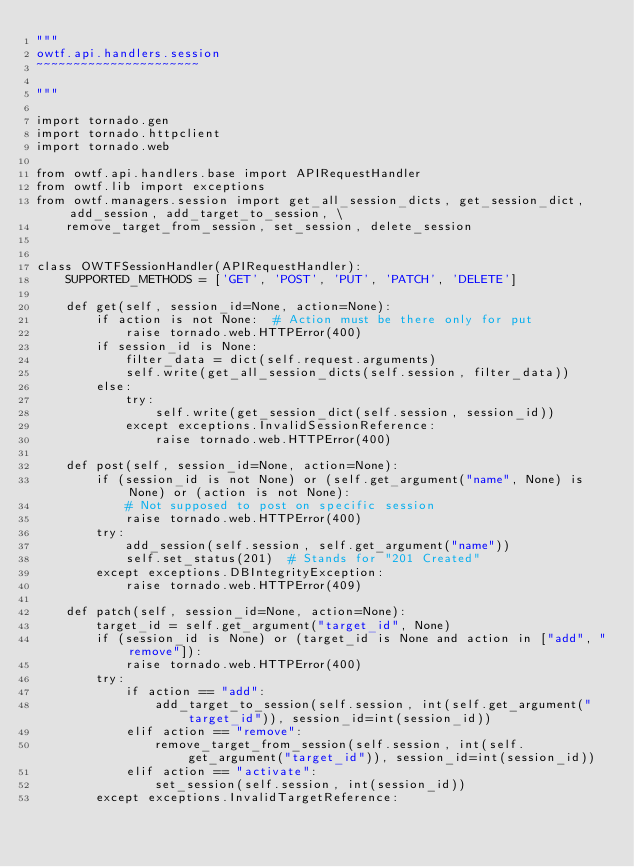Convert code to text. <code><loc_0><loc_0><loc_500><loc_500><_Python_>"""
owtf.api.handlers.session
~~~~~~~~~~~~~~~~~~~~~~

"""

import tornado.gen
import tornado.httpclient
import tornado.web

from owtf.api.handlers.base import APIRequestHandler
from owtf.lib import exceptions
from owtf.managers.session import get_all_session_dicts, get_session_dict, add_session, add_target_to_session, \
    remove_target_from_session, set_session, delete_session


class OWTFSessionHandler(APIRequestHandler):
    SUPPORTED_METHODS = ['GET', 'POST', 'PUT', 'PATCH', 'DELETE']

    def get(self, session_id=None, action=None):
        if action is not None:  # Action must be there only for put
            raise tornado.web.HTTPError(400)
        if session_id is None:
            filter_data = dict(self.request.arguments)
            self.write(get_all_session_dicts(self.session, filter_data))
        else:
            try:
                self.write(get_session_dict(self.session, session_id))
            except exceptions.InvalidSessionReference:
                raise tornado.web.HTTPError(400)

    def post(self, session_id=None, action=None):
        if (session_id is not None) or (self.get_argument("name", None) is None) or (action is not None):
            # Not supposed to post on specific session
            raise tornado.web.HTTPError(400)
        try:
            add_session(self.session, self.get_argument("name"))
            self.set_status(201)  # Stands for "201 Created"
        except exceptions.DBIntegrityException:
            raise tornado.web.HTTPError(409)

    def patch(self, session_id=None, action=None):
        target_id = self.get_argument("target_id", None)
        if (session_id is None) or (target_id is None and action in ["add", "remove"]):
            raise tornado.web.HTTPError(400)
        try:
            if action == "add":
                add_target_to_session(self.session, int(self.get_argument("target_id")), session_id=int(session_id))
            elif action == "remove":
                remove_target_from_session(self.session, int(self.get_argument("target_id")), session_id=int(session_id))
            elif action == "activate":
                set_session(self.session, int(session_id))
        except exceptions.InvalidTargetReference:</code> 